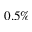Convert formula to latex. <formula><loc_0><loc_0><loc_500><loc_500>0 . 5 \%</formula> 